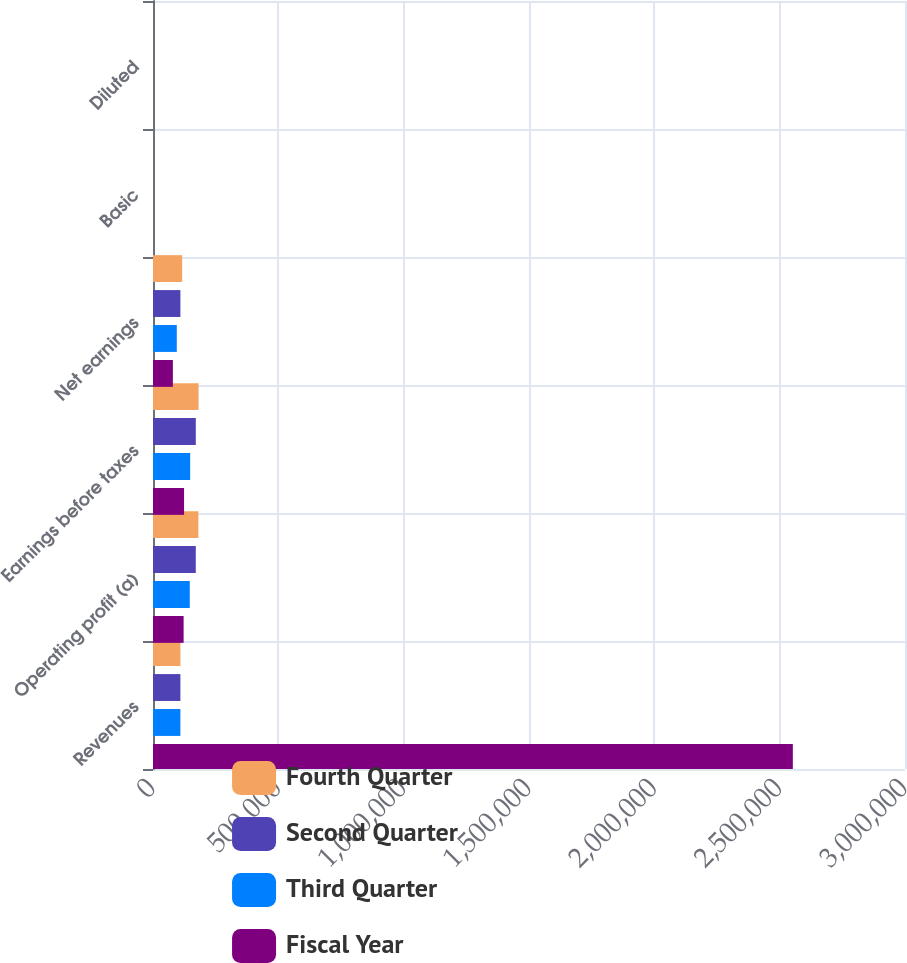<chart> <loc_0><loc_0><loc_500><loc_500><stacked_bar_chart><ecel><fcel>Revenues<fcel>Operating profit (a)<fcel>Earnings before taxes<fcel>Net earnings<fcel>Basic<fcel>Diluted<nl><fcel>Fourth Quarter<fcel>109287<fcel>181068<fcel>181815<fcel>116350<fcel>0.95<fcel>0.94<nl><fcel>Second Quarter<fcel>109287<fcel>170688<fcel>170744<fcel>109287<fcel>0.89<fcel>0.88<nl><fcel>Third Quarter<fcel>109287<fcel>146674<fcel>148281<fcel>94900<fcel>0.77<fcel>0.76<nl><fcel>Fiscal Year<fcel>2.55255e+06<fcel>122143<fcel>123933<fcel>79317<fcel>0.64<fcel>0.63<nl></chart> 